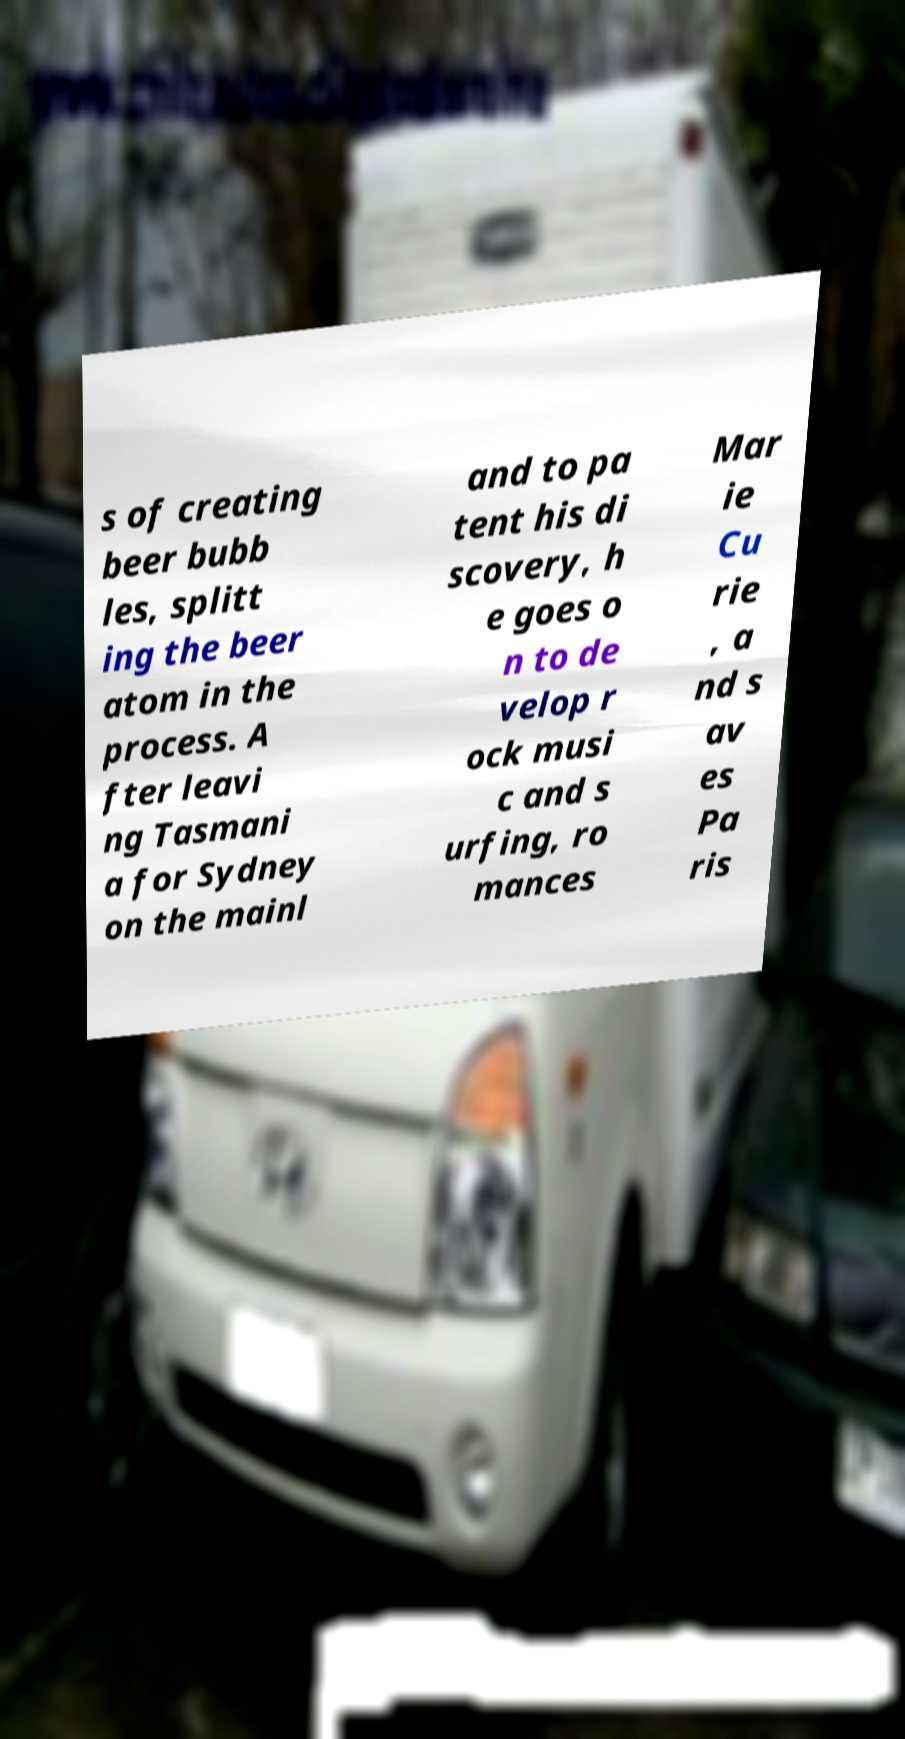Can you accurately transcribe the text from the provided image for me? s of creating beer bubb les, splitt ing the beer atom in the process. A fter leavi ng Tasmani a for Sydney on the mainl and to pa tent his di scovery, h e goes o n to de velop r ock musi c and s urfing, ro mances Mar ie Cu rie , a nd s av es Pa ris 